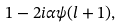<formula> <loc_0><loc_0><loc_500><loc_500>1 - 2 i \alpha \psi ( l + 1 ) ,</formula> 